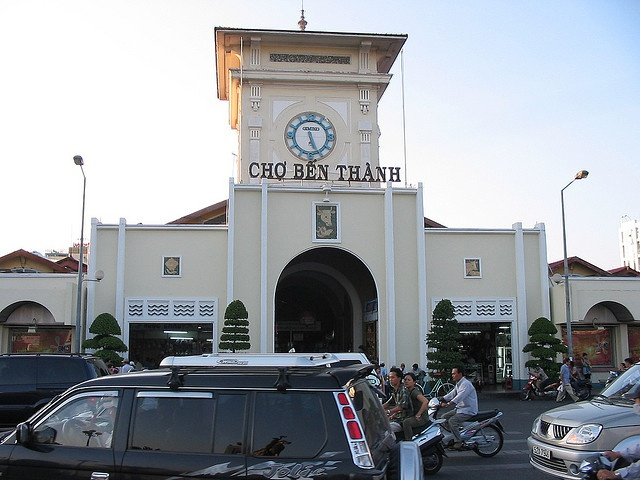Describe the objects in this image and their specific colors. I can see car in white, black, gray, and darkblue tones, car in white, darkgray, gray, and black tones, car in white, black, gray, and darkblue tones, motorcycle in white, black, gray, and darkblue tones, and clock in white, darkgray, and gray tones in this image. 